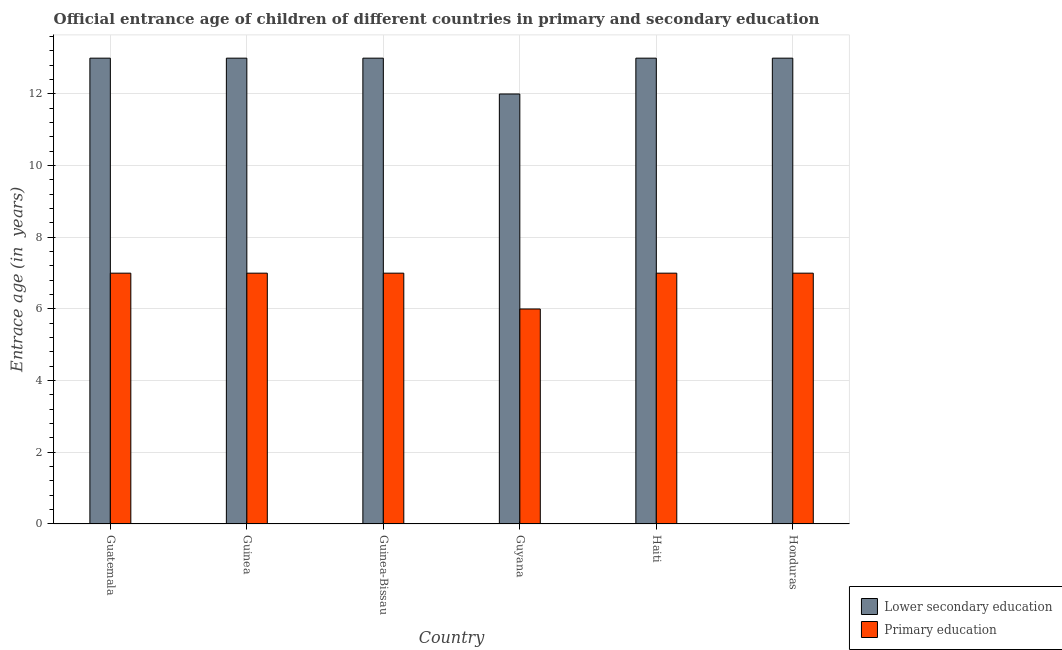How many different coloured bars are there?
Your answer should be compact. 2. How many groups of bars are there?
Provide a succinct answer. 6. Are the number of bars per tick equal to the number of legend labels?
Provide a short and direct response. Yes. How many bars are there on the 6th tick from the left?
Ensure brevity in your answer.  2. How many bars are there on the 6th tick from the right?
Your response must be concise. 2. What is the label of the 1st group of bars from the left?
Your response must be concise. Guatemala. What is the entrance age of chiildren in primary education in Guatemala?
Offer a very short reply. 7. Across all countries, what is the maximum entrance age of children in lower secondary education?
Offer a terse response. 13. Across all countries, what is the minimum entrance age of chiildren in primary education?
Ensure brevity in your answer.  6. In which country was the entrance age of children in lower secondary education maximum?
Give a very brief answer. Guatemala. In which country was the entrance age of children in lower secondary education minimum?
Your response must be concise. Guyana. What is the total entrance age of children in lower secondary education in the graph?
Give a very brief answer. 77. What is the difference between the entrance age of children in lower secondary education in Guatemala and that in Haiti?
Your answer should be very brief. 0. What is the average entrance age of chiildren in primary education per country?
Give a very brief answer. 6.83. What is the difference between the entrance age of chiildren in primary education and entrance age of children in lower secondary education in Honduras?
Give a very brief answer. -6. What is the ratio of the entrance age of chiildren in primary education in Guinea to that in Haiti?
Make the answer very short. 1. Is the difference between the entrance age of chiildren in primary education in Guinea and Guyana greater than the difference between the entrance age of children in lower secondary education in Guinea and Guyana?
Provide a short and direct response. No. What is the difference between the highest and the second highest entrance age of chiildren in primary education?
Your answer should be compact. 0. What is the difference between the highest and the lowest entrance age of children in lower secondary education?
Provide a succinct answer. 1. In how many countries, is the entrance age of chiildren in primary education greater than the average entrance age of chiildren in primary education taken over all countries?
Your answer should be very brief. 5. Is the sum of the entrance age of children in lower secondary education in Guyana and Haiti greater than the maximum entrance age of chiildren in primary education across all countries?
Your answer should be very brief. Yes. What does the 2nd bar from the left in Honduras represents?
Make the answer very short. Primary education. What does the 1st bar from the right in Guatemala represents?
Your answer should be compact. Primary education. Are the values on the major ticks of Y-axis written in scientific E-notation?
Your answer should be compact. No. Does the graph contain any zero values?
Offer a very short reply. No. Where does the legend appear in the graph?
Provide a short and direct response. Bottom right. How many legend labels are there?
Make the answer very short. 2. What is the title of the graph?
Your answer should be compact. Official entrance age of children of different countries in primary and secondary education. What is the label or title of the X-axis?
Give a very brief answer. Country. What is the label or title of the Y-axis?
Make the answer very short. Entrace age (in  years). What is the Entrace age (in  years) of Primary education in Guinea-Bissau?
Ensure brevity in your answer.  7. What is the Entrace age (in  years) in Lower secondary education in Guyana?
Your response must be concise. 12. What is the Entrace age (in  years) of Primary education in Guyana?
Your response must be concise. 6. What is the Entrace age (in  years) in Primary education in Haiti?
Offer a very short reply. 7. What is the Entrace age (in  years) in Lower secondary education in Honduras?
Your answer should be compact. 13. Across all countries, what is the maximum Entrace age (in  years) of Lower secondary education?
Your response must be concise. 13. Across all countries, what is the maximum Entrace age (in  years) of Primary education?
Keep it short and to the point. 7. What is the total Entrace age (in  years) of Lower secondary education in the graph?
Provide a succinct answer. 77. What is the difference between the Entrace age (in  years) in Lower secondary education in Guatemala and that in Guinea?
Your response must be concise. 0. What is the difference between the Entrace age (in  years) in Lower secondary education in Guatemala and that in Guinea-Bissau?
Your response must be concise. 0. What is the difference between the Entrace age (in  years) of Primary education in Guatemala and that in Guinea-Bissau?
Make the answer very short. 0. What is the difference between the Entrace age (in  years) of Lower secondary education in Guatemala and that in Guyana?
Offer a terse response. 1. What is the difference between the Entrace age (in  years) of Primary education in Guatemala and that in Guyana?
Your answer should be very brief. 1. What is the difference between the Entrace age (in  years) in Lower secondary education in Guatemala and that in Haiti?
Your response must be concise. 0. What is the difference between the Entrace age (in  years) of Primary education in Guatemala and that in Honduras?
Ensure brevity in your answer.  0. What is the difference between the Entrace age (in  years) of Lower secondary education in Guinea and that in Guinea-Bissau?
Offer a terse response. 0. What is the difference between the Entrace age (in  years) in Lower secondary education in Guinea and that in Guyana?
Keep it short and to the point. 1. What is the difference between the Entrace age (in  years) in Primary education in Guinea and that in Haiti?
Offer a very short reply. 0. What is the difference between the Entrace age (in  years) of Lower secondary education in Guinea and that in Honduras?
Provide a succinct answer. 0. What is the difference between the Entrace age (in  years) in Primary education in Guinea and that in Honduras?
Provide a succinct answer. 0. What is the difference between the Entrace age (in  years) of Primary education in Guinea-Bissau and that in Guyana?
Give a very brief answer. 1. What is the difference between the Entrace age (in  years) in Lower secondary education in Guinea-Bissau and that in Haiti?
Ensure brevity in your answer.  0. What is the difference between the Entrace age (in  years) in Primary education in Guinea-Bissau and that in Haiti?
Provide a succinct answer. 0. What is the difference between the Entrace age (in  years) in Primary education in Guyana and that in Honduras?
Provide a short and direct response. -1. What is the difference between the Entrace age (in  years) in Lower secondary education in Guatemala and the Entrace age (in  years) in Primary education in Guinea?
Make the answer very short. 6. What is the difference between the Entrace age (in  years) in Lower secondary education in Guatemala and the Entrace age (in  years) in Primary education in Guinea-Bissau?
Keep it short and to the point. 6. What is the difference between the Entrace age (in  years) of Lower secondary education in Guatemala and the Entrace age (in  years) of Primary education in Haiti?
Ensure brevity in your answer.  6. What is the difference between the Entrace age (in  years) in Lower secondary education in Guatemala and the Entrace age (in  years) in Primary education in Honduras?
Your answer should be compact. 6. What is the difference between the Entrace age (in  years) in Lower secondary education in Guinea and the Entrace age (in  years) in Primary education in Guinea-Bissau?
Your answer should be very brief. 6. What is the difference between the Entrace age (in  years) in Lower secondary education in Guinea-Bissau and the Entrace age (in  years) in Primary education in Guyana?
Your response must be concise. 7. What is the difference between the Entrace age (in  years) in Lower secondary education in Guinea-Bissau and the Entrace age (in  years) in Primary education in Haiti?
Offer a very short reply. 6. What is the difference between the Entrace age (in  years) of Lower secondary education in Guinea-Bissau and the Entrace age (in  years) of Primary education in Honduras?
Your answer should be compact. 6. What is the difference between the Entrace age (in  years) in Lower secondary education in Guyana and the Entrace age (in  years) in Primary education in Honduras?
Keep it short and to the point. 5. What is the difference between the Entrace age (in  years) of Lower secondary education in Haiti and the Entrace age (in  years) of Primary education in Honduras?
Give a very brief answer. 6. What is the average Entrace age (in  years) of Lower secondary education per country?
Your answer should be compact. 12.83. What is the average Entrace age (in  years) in Primary education per country?
Make the answer very short. 6.83. What is the difference between the Entrace age (in  years) in Lower secondary education and Entrace age (in  years) in Primary education in Guatemala?
Make the answer very short. 6. What is the ratio of the Entrace age (in  years) of Lower secondary education in Guatemala to that in Guinea?
Offer a very short reply. 1. What is the ratio of the Entrace age (in  years) in Primary education in Guatemala to that in Guinea-Bissau?
Offer a terse response. 1. What is the ratio of the Entrace age (in  years) in Primary education in Guatemala to that in Guyana?
Provide a succinct answer. 1.17. What is the ratio of the Entrace age (in  years) in Lower secondary education in Guatemala to that in Haiti?
Offer a terse response. 1. What is the ratio of the Entrace age (in  years) of Primary education in Guatemala to that in Honduras?
Offer a terse response. 1. What is the ratio of the Entrace age (in  years) in Lower secondary education in Guinea to that in Guinea-Bissau?
Your answer should be very brief. 1. What is the ratio of the Entrace age (in  years) of Primary education in Guinea to that in Guyana?
Give a very brief answer. 1.17. What is the ratio of the Entrace age (in  years) of Primary education in Guinea-Bissau to that in Guyana?
Offer a very short reply. 1.17. What is the ratio of the Entrace age (in  years) in Primary education in Guinea-Bissau to that in Honduras?
Your answer should be compact. 1. What is the ratio of the Entrace age (in  years) of Primary education in Guyana to that in Haiti?
Provide a succinct answer. 0.86. What is the ratio of the Entrace age (in  years) of Lower secondary education in Guyana to that in Honduras?
Offer a terse response. 0.92. What is the ratio of the Entrace age (in  years) in Primary education in Haiti to that in Honduras?
Give a very brief answer. 1. What is the difference between the highest and the lowest Entrace age (in  years) of Lower secondary education?
Your answer should be very brief. 1. 